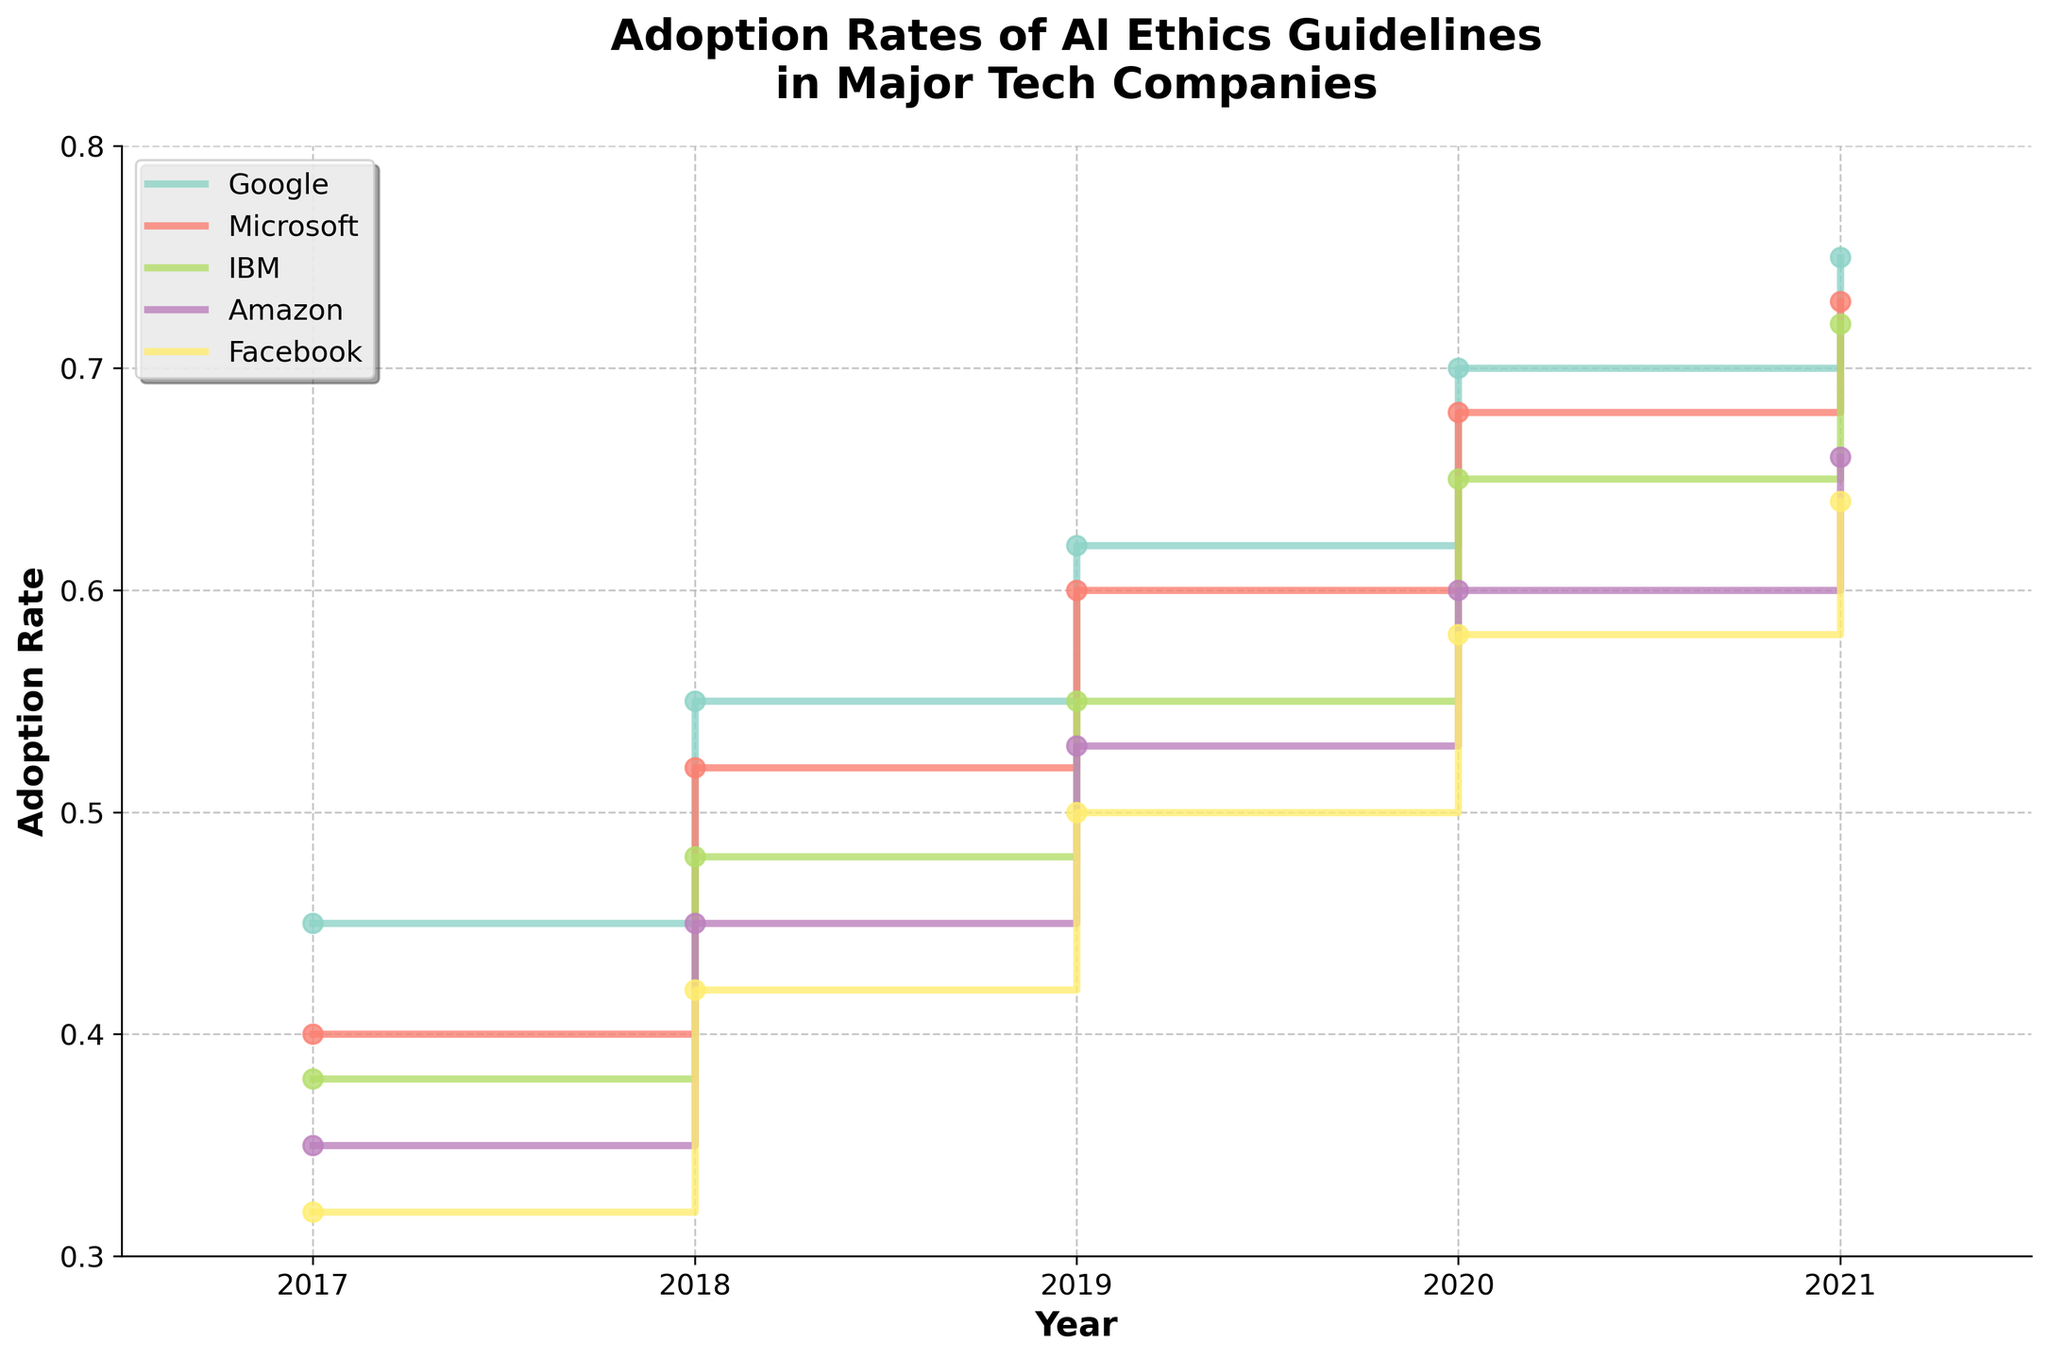What's the title of the figure? The title is usually positioned at the top of the figure, prominently displayed for clarity. The title can be used to understand the main topic the figure addresses.
Answer: Adoption Rates of AI Ethics Guidelines in Major Tech Companies Which company had the highest adoption rate in 2021? To determine this, we need to look at the end of each line for various companies in 2021 and find the one with the highest final value. By inspecting the plot, we can compare them directly.
Answer: Google How did Amazon's adoption rate change from 2017 to 2020? This requires checking Amazon's adoption rate in 2017 and in 2020 and then calculating the difference between these two values. Based on the data points, we can see the rates and compute the difference.
Answer: Increased by 0.25 What is the average adoption rate increase per year for IBM from 2017 to 2021? First, find IBM's adoption rates for 2017 and 2021. Next, calculate the total increase over these years and then divide it by the number of years (4) to get the average annual increase.
Answer: 0.085 Between Google and Microsoft, which company showed a larger increase in adoption rates from 2018 to 2019? Identify the adoption rates for both companies in 2018 and 2019, then calculate the difference for each and compare the results to determine which had the larger increase. Google: 0.62 - 0.55 = 0.07, Microsoft: 0.60 - 0.52 = 0.08. Microsoft has the larger increase.
Answer: Microsoft Did any company experience a decrease in adoption rate within the years shown? Check each company's year-on-year adoption rate values. If any company's value decreases from one year to the next, that company experienced a decrease. Checking all lines, there is no decrease for any company.
Answer: No Which company had the smallest increase in adoption rate from 2017 to 2021? Find the adoption rates for all companies in 2017 and 2021. Calculate the increase for each company and compare them to identify the smallest increase.
Answer: Facebook How does the general trend of adoption rates appear from 2017 to 2021? To determine the general trend, observe the overall direction of the lines representing each company from 2017 through 2021.
Answer: Upward trend 